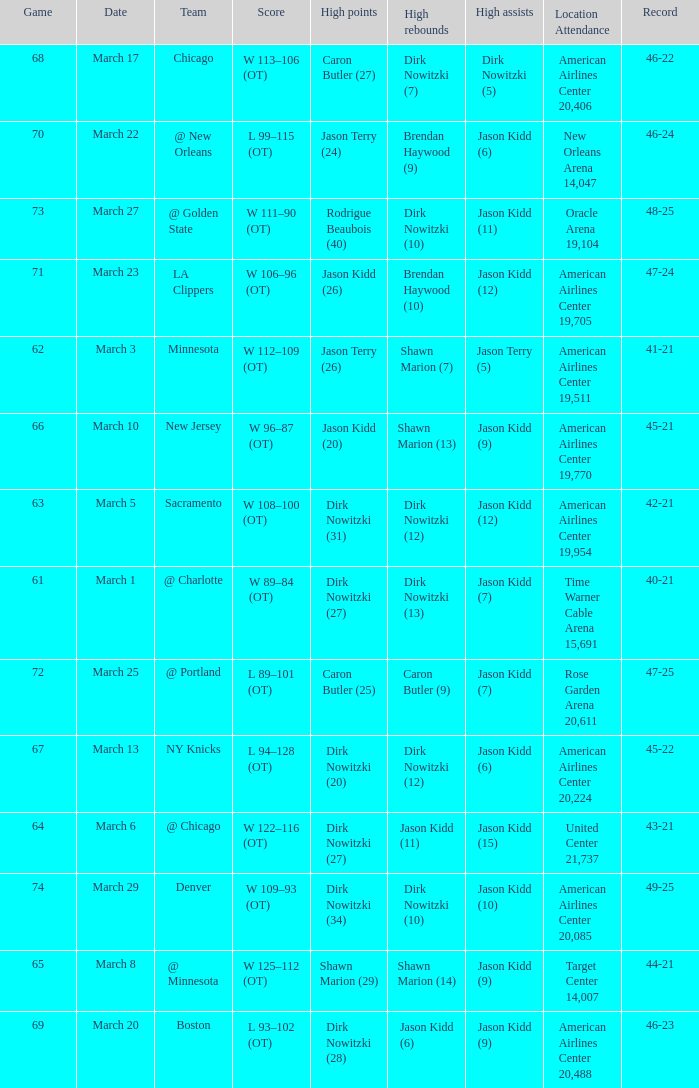How many games had been played when the Mavericks had a 46-22 record? 68.0. 